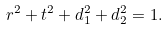Convert formula to latex. <formula><loc_0><loc_0><loc_500><loc_500>r ^ { 2 } + t ^ { 2 } + d _ { 1 } ^ { 2 } + d _ { 2 } ^ { 2 } = 1 .</formula> 